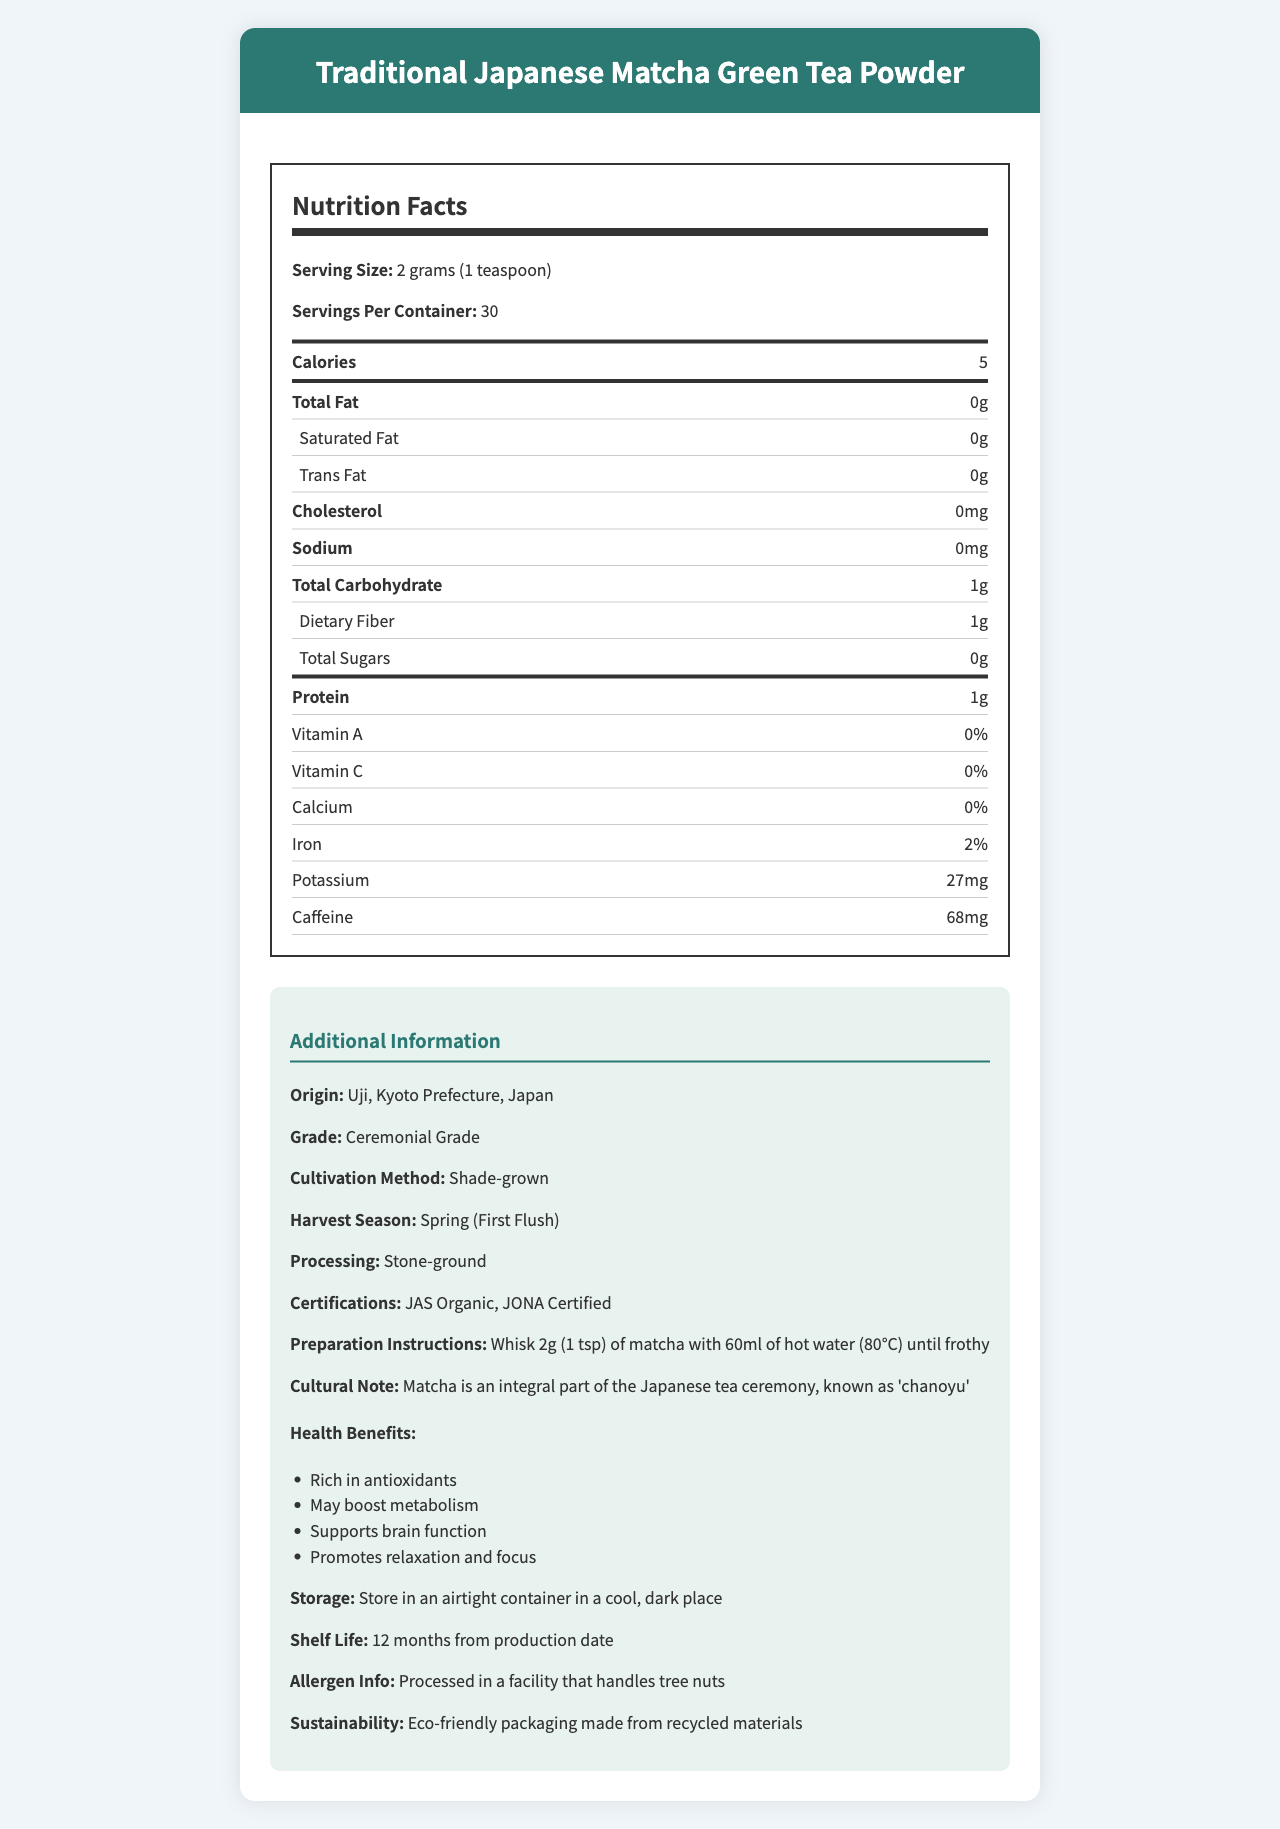what is the serving size of the Matcha green tea powder? The document mentions that the serving size is 2 grams, which is equivalent to 1 teaspoon.
Answer: 2 grams (1 teaspoon) how many calories are in one serving of the matcha powder? The nutrition label specifies that one serving (2 grams) contains 5 calories.
Answer: 5 how much protein does one serving of the matcha powder contain? According to the nutrition label, one serving has 1 gram of protein.
Answer: 1 gram what are the antioxidant components listed in the nutrition facts? The nutrition label includes a section for antioxidants, specifying Catechins (105 mg) and Epigallocatechin Gallate (61 mg).
Answer: Catechins (105 mg), Epigallocatechin Gallate (61 mg) how should you prepare a serving of this matcha green tea powder? The preparation instructions provided in the document recommend whisking 2 grams (1 teaspoon) of matcha with 60ml of hot water at 80°C until it becomes frothy.
Answer: Whisk 2g (1 tsp) of matcha with 60ml of hot water (80°C) until frothy where does the matcha green tea powder originate from? The document states that the origin of the product is Uji, Kyoto Prefecture in Japan.
Answer: Uji, Kyoto Prefecture, Japan what is the grade of the matcha green tea powder? The additional information section in the document describes the product as Ceremonial Grade.
Answer: Ceremonial Grade which cultivation method is used for this matcha green tea powder? The document mentions that the matcha is cultivated using the shade-grown method.
Answer: Shade-grown how many servings are there per container? The nutrition label specifies that there are 30 servings per container.
Answer: 30 which of the following certifications does the matcha green tea powder have? A. USDA Organic B. JAS Organic C. Fair Trade Certified D. Non-GMO The document lists JAS Organic and JONA Certified as the certifications the product holds.
Answer: B how many grams of dietary fiber are in one serving? A. 0 B. 0.5 C. 1 D. 2 The nutrition label states that one serving contains 1 gram of dietary fiber.
Answer: C does the matcha green tea powder contain any added sugars? The label specifies that the total sugars per serving are 0 grams, indicating no added sugars.
Answer: No is the matcha green tea powder's packaging eco-friendly? The document specifies that the packaging is made from recycled materials, indicating eco-friendliness.
Answer: Yes summarize the main aspects of the matcha green tea powder nutrition facts and additional information. The summary captures the key nutritional facts (calories, protein, fiber, antioxidants), product details (origin, cultivation, processing, certifications), and additional cultural and health-related information.
Answer: The document provides nutritional information and additional details about the Traditional Japanese Matcha Green Tea Powder. Each serving (2 grams) contains 5 calories, 1g of dietary fiber, 1g of protein, and notable antioxidants (Catechins and Epigallocatechin Gallate). The product is Ceremonial Grade, shade-grown in Uji, Kyoto, and processed using stone-ground methods. It has certifications like JAS Organic and JONA Certified. Preparation involves whisking 2g with 60ml of hot water. Matcha is culturally significant in Japanese tea ceremonies and offers health benefits like boosting metabolism and supporting brain function. what are the health benefits associated with the matcha green tea powder? The document lists several health benefits, including being rich in antioxidants, boosting metabolism, supporting brain function, and promoting relaxation and focus.
Answer: Rich in antioxidants, may boost metabolism, supports brain function, promotes relaxation and focus is Vitamin C present in the matcha green tea powder? The nutrition label indicates that Vitamin C is at 0%, indicating it is not present in the matcha green tea powder.
Answer: No what is the cultivation method used for this matcha green tea? The document mentions that the matcha green tea powder is shade-grown, but without specific details on how 'shade-grown' is implemented. Thus, someone might need more details to understand the entire cultivation process.
Answer: Not enough information 